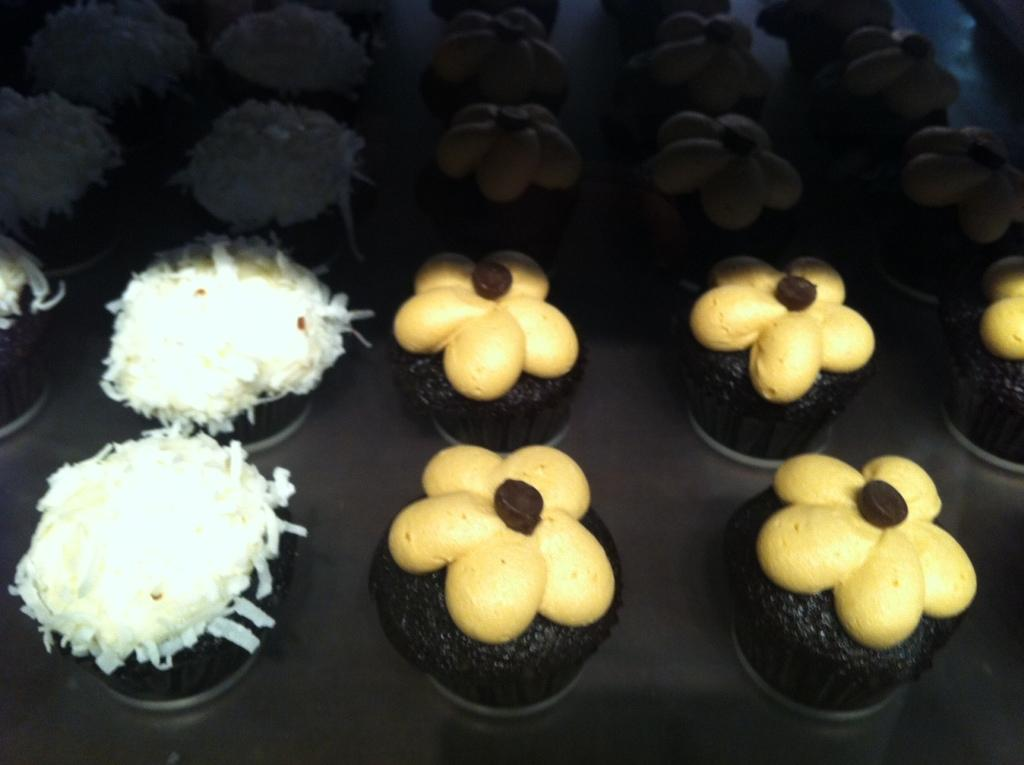What type of food can be seen on the tray in the image? There are desserts placed on a tray in the image. What type of flesh can be seen on the desserts in the image? There is no flesh present on the desserts in the image. 